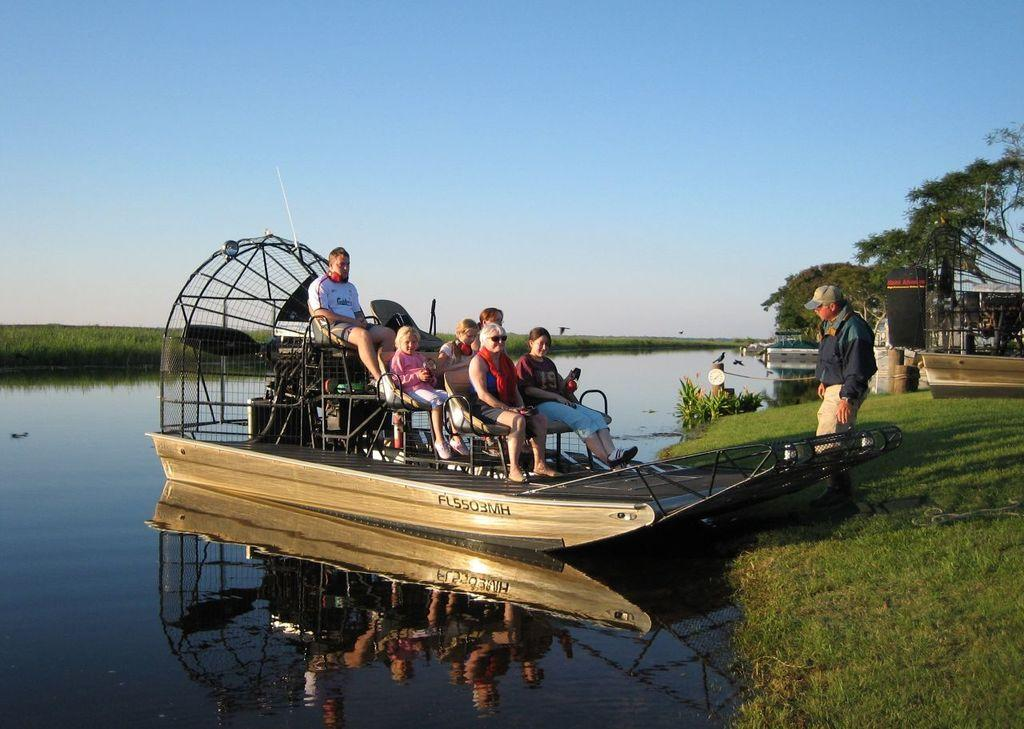What are the people in the image doing? The people in the image are sitting in a boat. What can be seen at the right side of the image? There is a person walking at the right side of the image. What type of body of water is present in the image? There is a lake in the image. What type of vegetation is visible in the image? There is grass and trees visible in the image. What is the condition of the sky in the image? The sky is clear in the image. What color of paint is being used by the brother in the image? There is no brother or paint present in the image. What act is the person walking at the right side of the image performing? The person walking at the right side of the image is not performing any specific act; they are simply walking. 